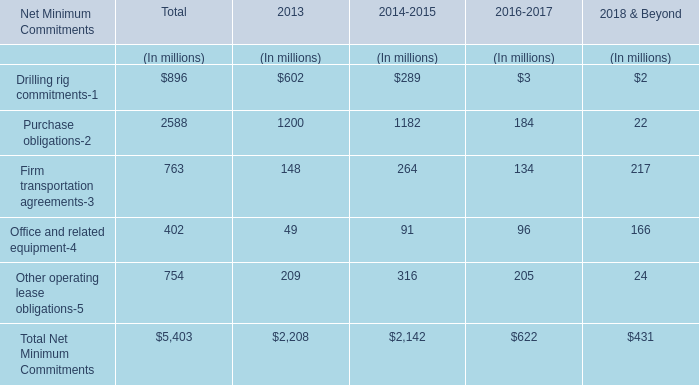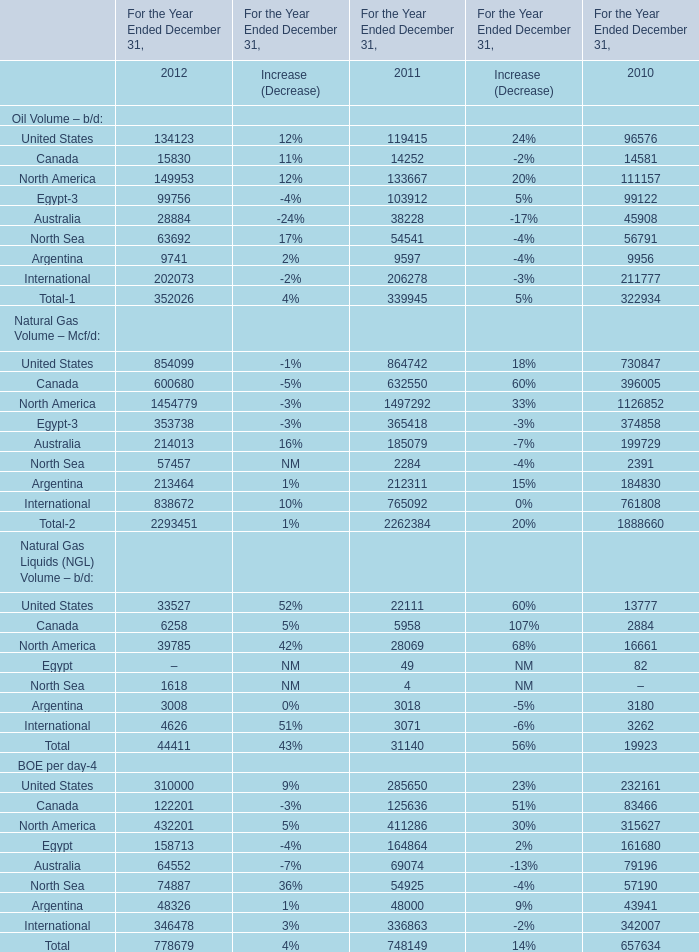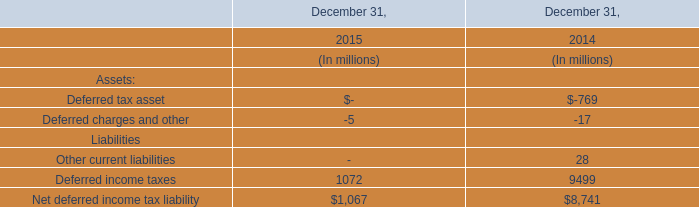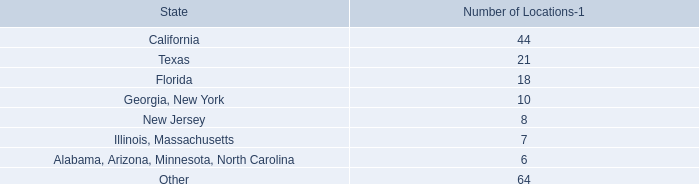what percentage of total leased locations are located in united states? 
Computations: (64 / (72 + 64))
Answer: 0.47059. 